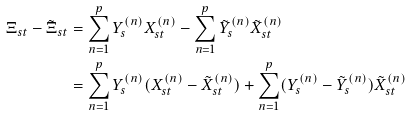<formula> <loc_0><loc_0><loc_500><loc_500>\Xi _ { s t } - \tilde { \Xi } _ { s t } & = \sum _ { n = 1 } ^ { p } Y _ { s } ^ { ( n ) } X _ { s t } ^ { ( n ) } - \sum _ { n = 1 } ^ { p } \tilde { Y } _ { s } ^ { ( n ) } \tilde { X } _ { s t } ^ { ( n ) } \\ & = \sum _ { n = 1 } ^ { p } Y _ { s } ^ { ( n ) } ( X _ { s t } ^ { ( n ) } - \tilde { X } _ { s t } ^ { ( n ) } ) + \sum _ { n = 1 } ^ { p } ( Y _ { s } ^ { ( n ) } - \tilde { Y } _ { s } ^ { ( n ) } ) \tilde { X } _ { s t } ^ { ( n ) }</formula> 